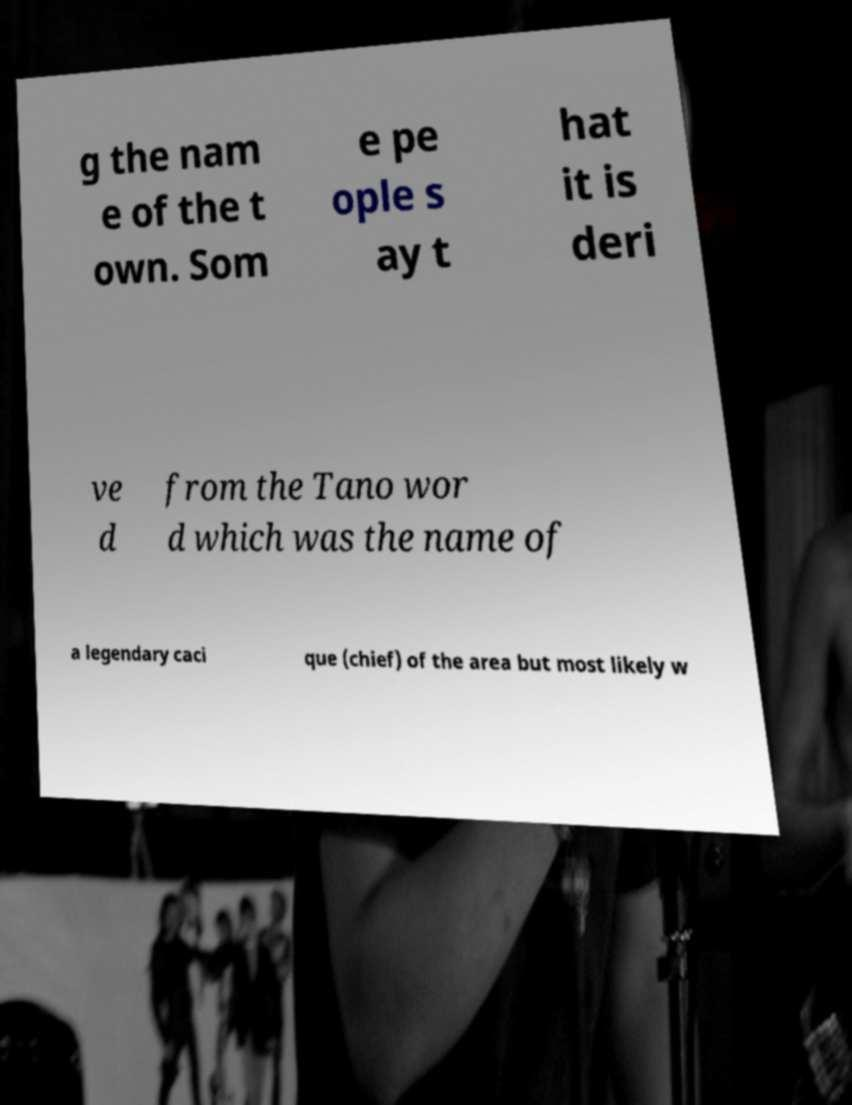Please identify and transcribe the text found in this image. g the nam e of the t own. Som e pe ople s ay t hat it is deri ve d from the Tano wor d which was the name of a legendary caci que (chief) of the area but most likely w 